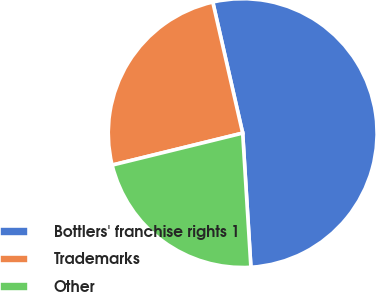<chart> <loc_0><loc_0><loc_500><loc_500><pie_chart><fcel>Bottlers' franchise rights 1<fcel>Trademarks<fcel>Other<nl><fcel>52.6%<fcel>25.26%<fcel>22.15%<nl></chart> 